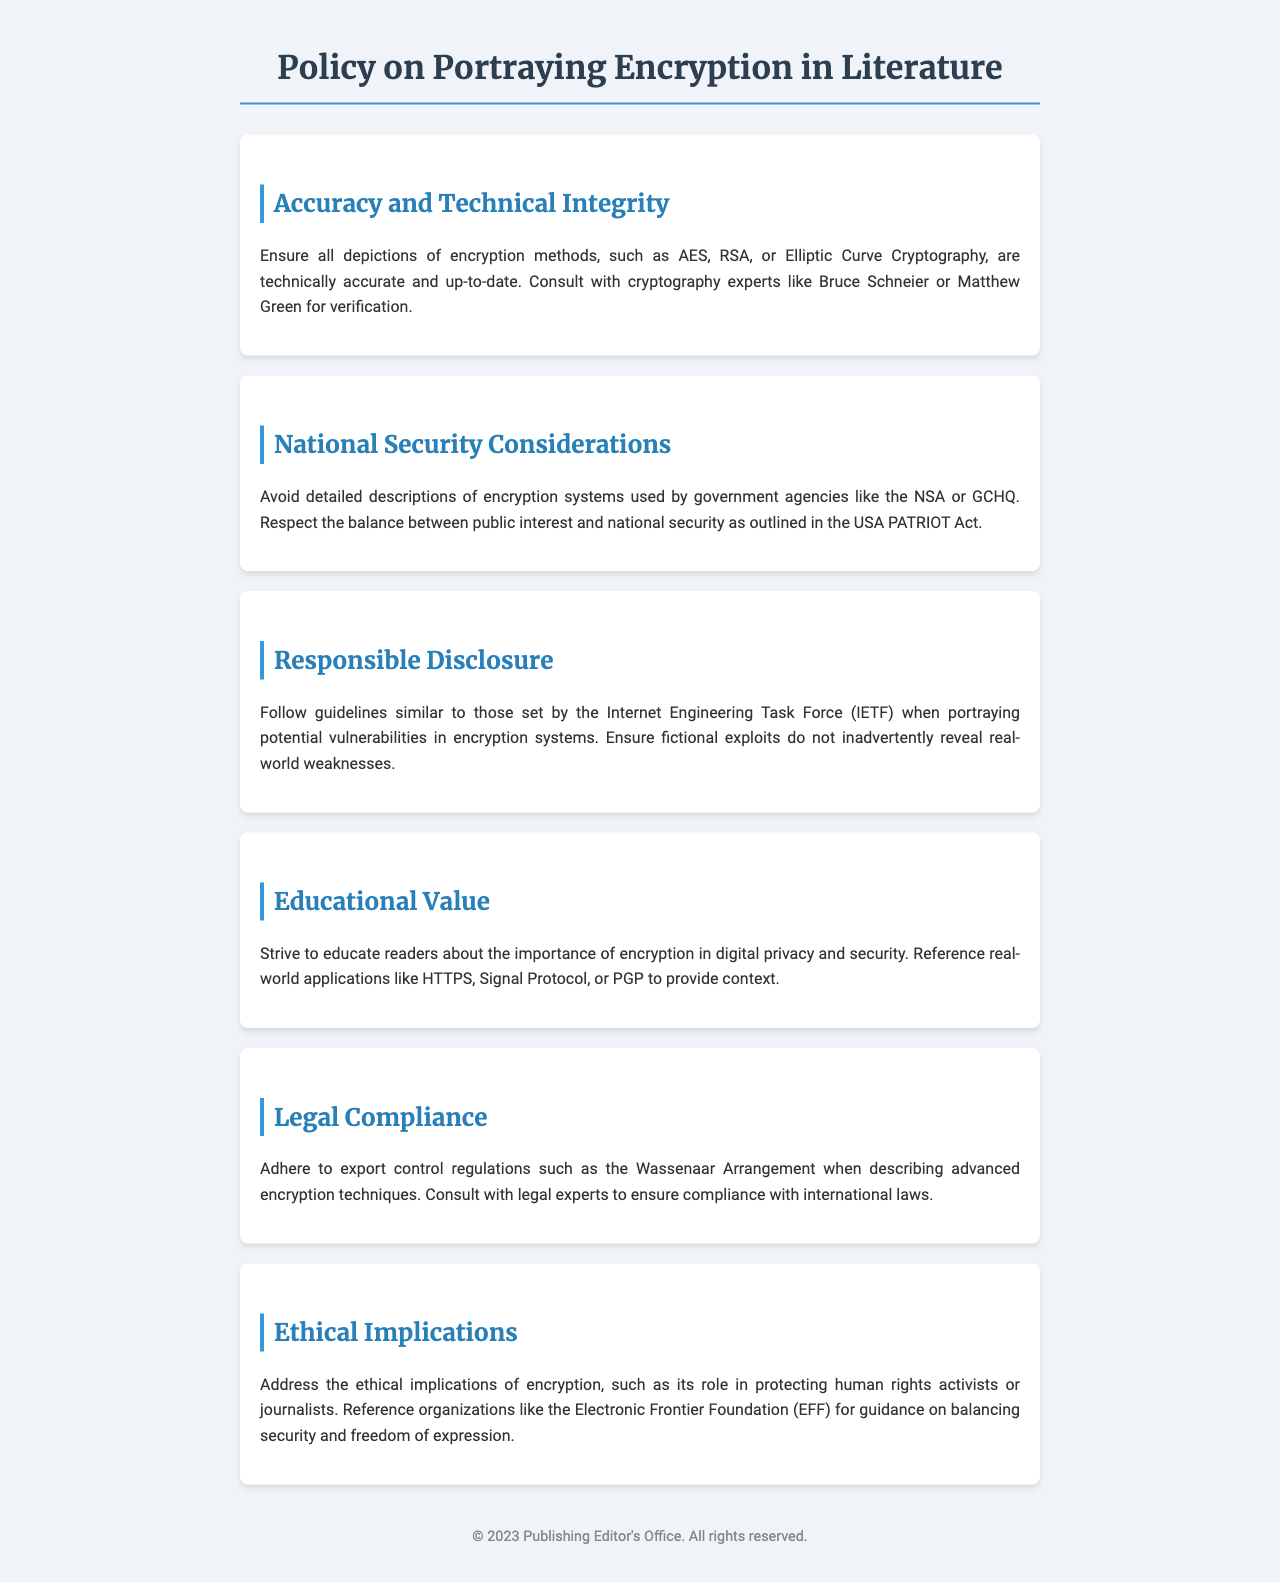What is the title of the document? The title is stated at the top of the document, indicating its focus on encryption in literature.
Answer: Policy on Portraying Encryption in Literature Who is an expert recommended for consultation? The document lists prominent figures in the field of cryptography for verification of technical accuracy.
Answer: Bruce Schneier What is mentioned as a guideline for responsible disclosure? It suggests following guidelines similar to those established by a well-known organization focused on internet standards.
Answer: Internet Engineering Task Force Which encryption system should be avoided in descriptions? The document specifies a couple of agencies wherein detailed descriptions of their systems should be avoided.
Answer: NSA What is the importance of encryption emphasized in the document? It highlights a crucial aspect of modern digital society that encryption supports, especially in privacy.
Answer: Digital privacy and security What ethical organization is referenced for guidance? The document cites an organization known for advocating user rights and digital liberties.
Answer: Electronic Frontier Foundation What year is indicated in the footer? The footer provides a year relevant to the publishing information of the document.
Answer: 2023 Name a real-world application referenced in the educational value section. The document provides specific examples of real-world technologies that utilize encryption.
Answer: HTTPS 